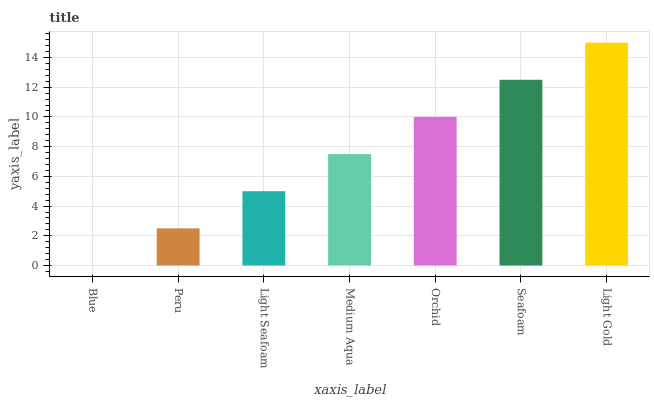Is Blue the minimum?
Answer yes or no. Yes. Is Light Gold the maximum?
Answer yes or no. Yes. Is Peru the minimum?
Answer yes or no. No. Is Peru the maximum?
Answer yes or no. No. Is Peru greater than Blue?
Answer yes or no. Yes. Is Blue less than Peru?
Answer yes or no. Yes. Is Blue greater than Peru?
Answer yes or no. No. Is Peru less than Blue?
Answer yes or no. No. Is Medium Aqua the high median?
Answer yes or no. Yes. Is Medium Aqua the low median?
Answer yes or no. Yes. Is Light Gold the high median?
Answer yes or no. No. Is Light Seafoam the low median?
Answer yes or no. No. 